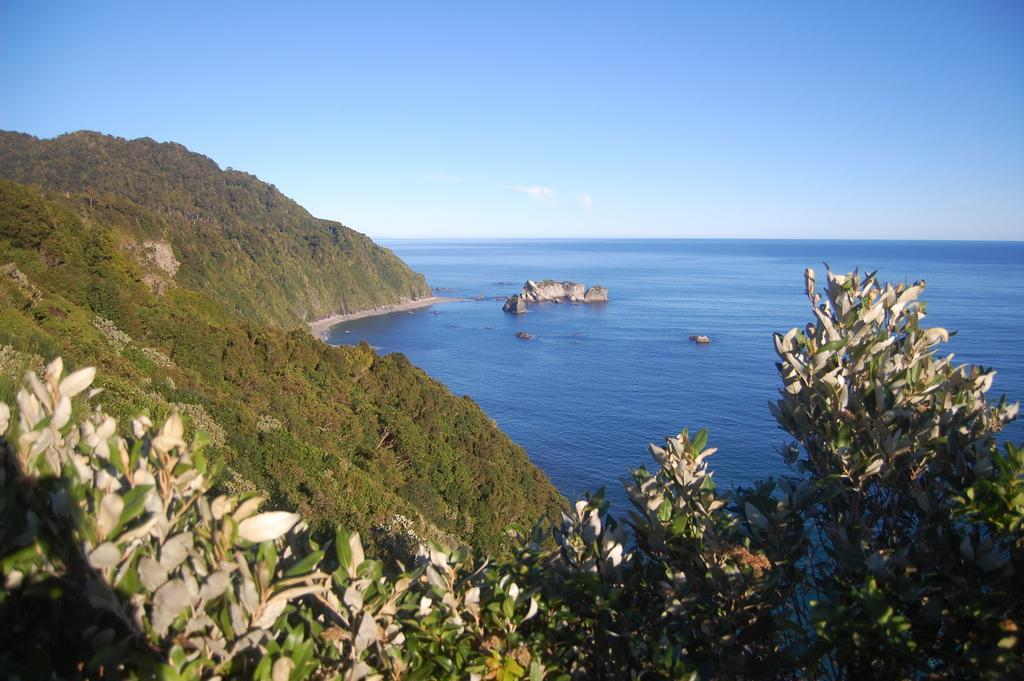Describe this image in one or two sentences. In this image there are trees, rocks, water and sky. 